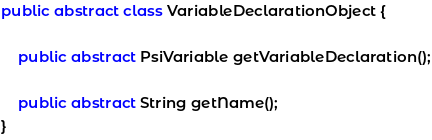Convert code to text. <code><loc_0><loc_0><loc_500><loc_500><_Java_>
public abstract class VariableDeclarationObject {

    public abstract PsiVariable getVariableDeclaration();

    public abstract String getName();
}
</code> 